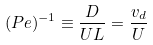<formula> <loc_0><loc_0><loc_500><loc_500>( P e ) ^ { - 1 } \equiv \frac { D } { U L } = \frac { v _ { d } } { U }</formula> 